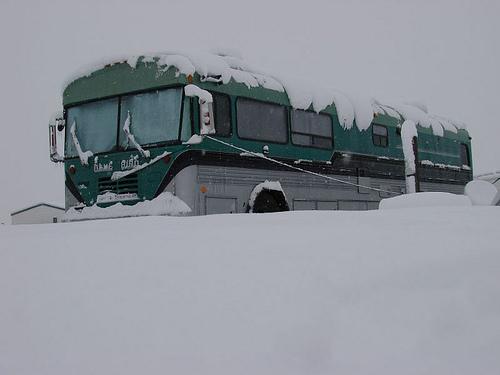What color is the bus?
Write a very short answer. Green. Is there a heart visible?
Write a very short answer. No. What color is the snow?
Concise answer only. White. Is the bus covered with snow?
Concise answer only. Yes. 